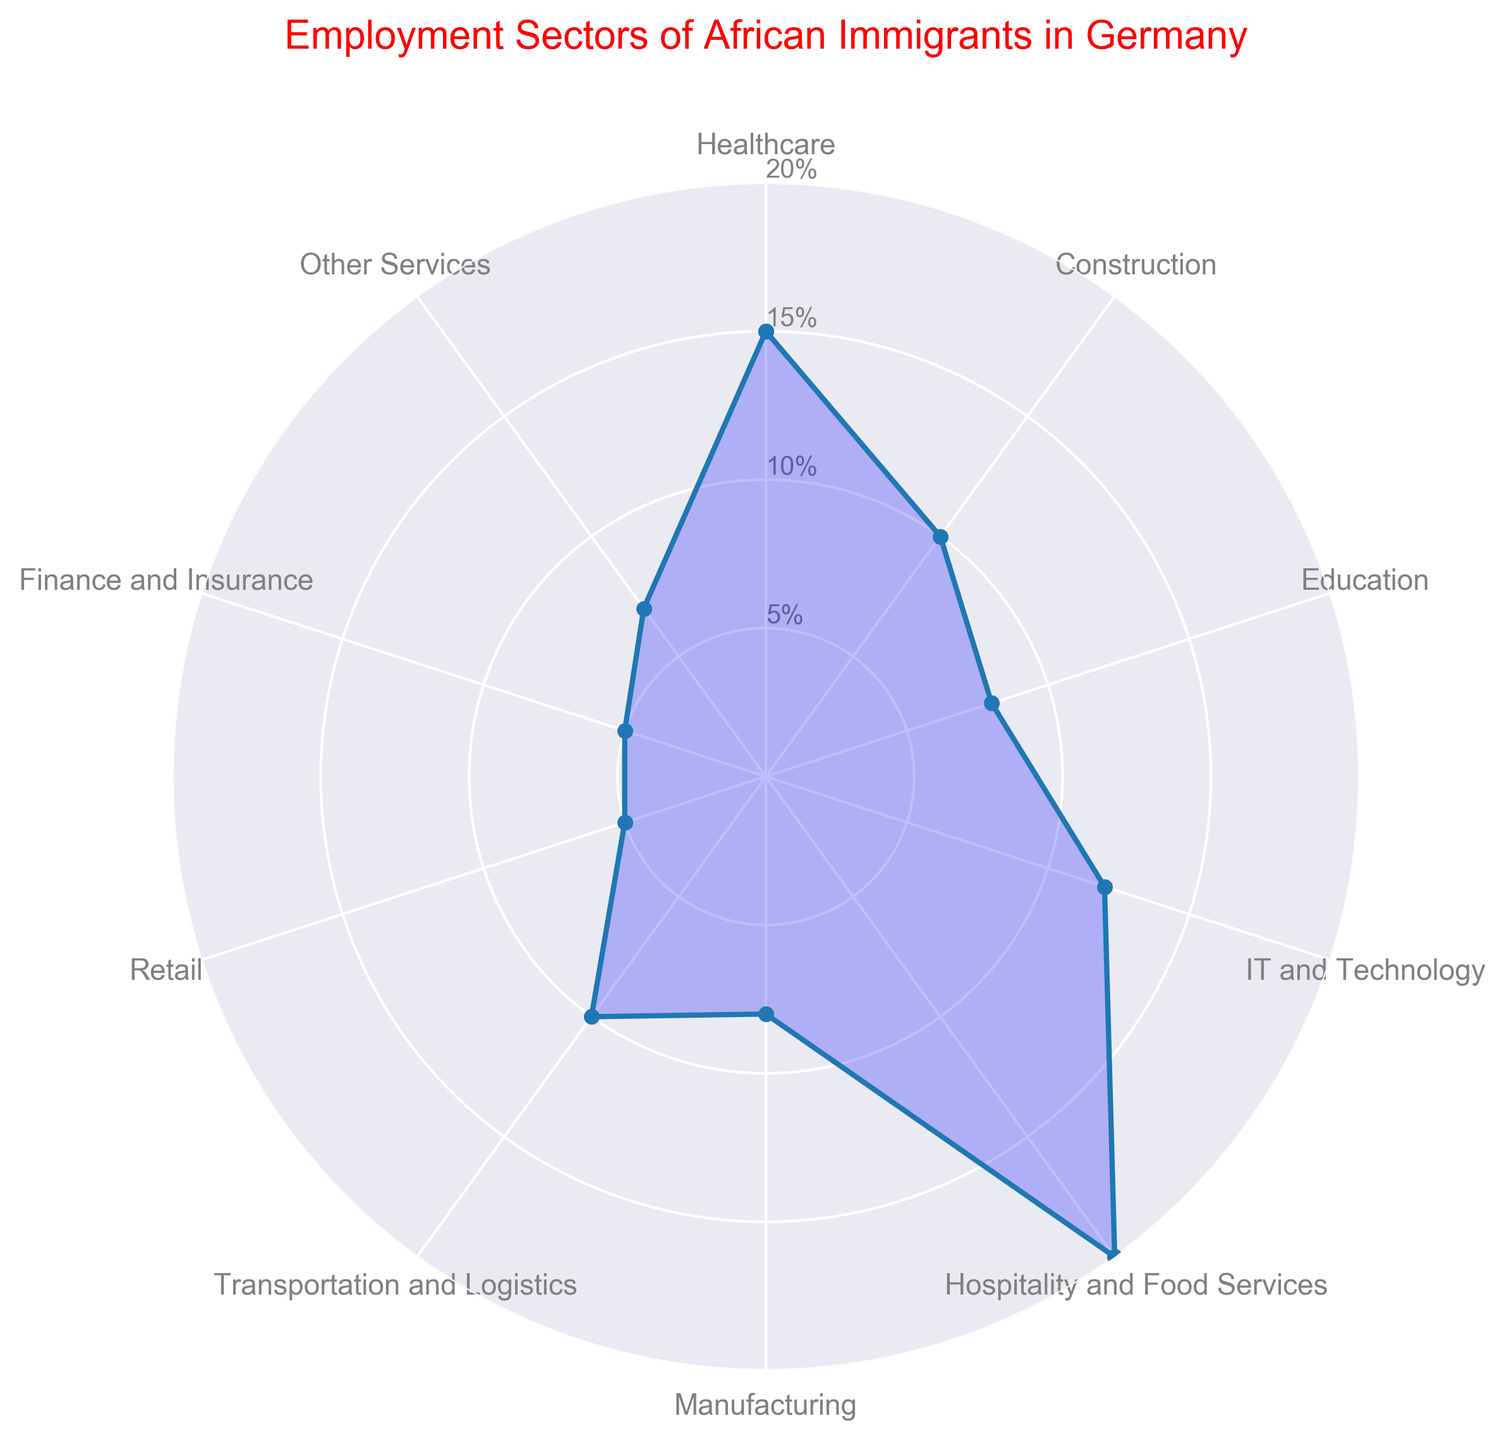Which sector has the highest percentage of employment among African immigrants in Germany? The Hospitality and Food Services sector shows the highest percentage at 20% on the radar chart.
Answer: Hospitality and Food Services Which two sectors have the same percentage of employment? The radar chart indicates that Retail and Finance and Insurance sectors both have a 5% employment rate.
Answer: Retail and Finance and Insurance What is the combined percentage of employment in the Healthcare and IT and Technology sectors? The percentages for Healthcare and IT and Technology sectors are 15% and 12%, respectively. Adding these together gives 15% + 12% = 27%.
Answer: 27% Which sector has a higher employment percentage, Transportation and Logistics or Education? Transportation and Logistics has a 10% employment rate, while Education has an 8% employment rate, making Transportation and Logistics higher.
Answer: Transportation and Logistics How many sectors have an employment percentage of 8%? The radar chart shows that sectors Education and Manufacturing both have 8% employment, making it two sectors.
Answer: Two Is the percentage of employment in Construction greater than that in Other Services? Yes, the Construction sector has a 10% employment rate which is greater than the 7% employment rate for Other Services.
Answer: Yes What is the difference in employment percentage between the sector with the highest and the lowest rates? The highest rate is in Hospitality and Food Services at 20%, and the lowest rate is in Retail and Finance and Insurance sectors each at 5%. The difference is 20% - 5% = 15%.
Answer: 15% What sectors have an employment percentage higher than that of the Manufacturing sector? Sectors with higher employment percentages than Manufacturing's 8% are Healthcare (15%), IT and Technology (12%), Hospitality and Food Services (20%), and Transportation and Logistics (10%).
Answer: Healthcare, IT and Technology, Hospitality and Food Services, Transportation and Logistics What is the average employment percentage for the sectors listed on the radar chart? Adding all the percentages together (15 + 10 + 8 + 12 + 20 + 8 + 10 + 5 + 5 + 7) results in 100%. Dividing this by the number of sectors, which is 10, gives an average of 100% / 10 = 10%.
Answer: 10% Which sector has the second highest percentage of employment? The sector with the second highest employment rate after Hospitality and Food Services (20%) is Healthcare, which has a 15% rate.
Answer: Healthcare 